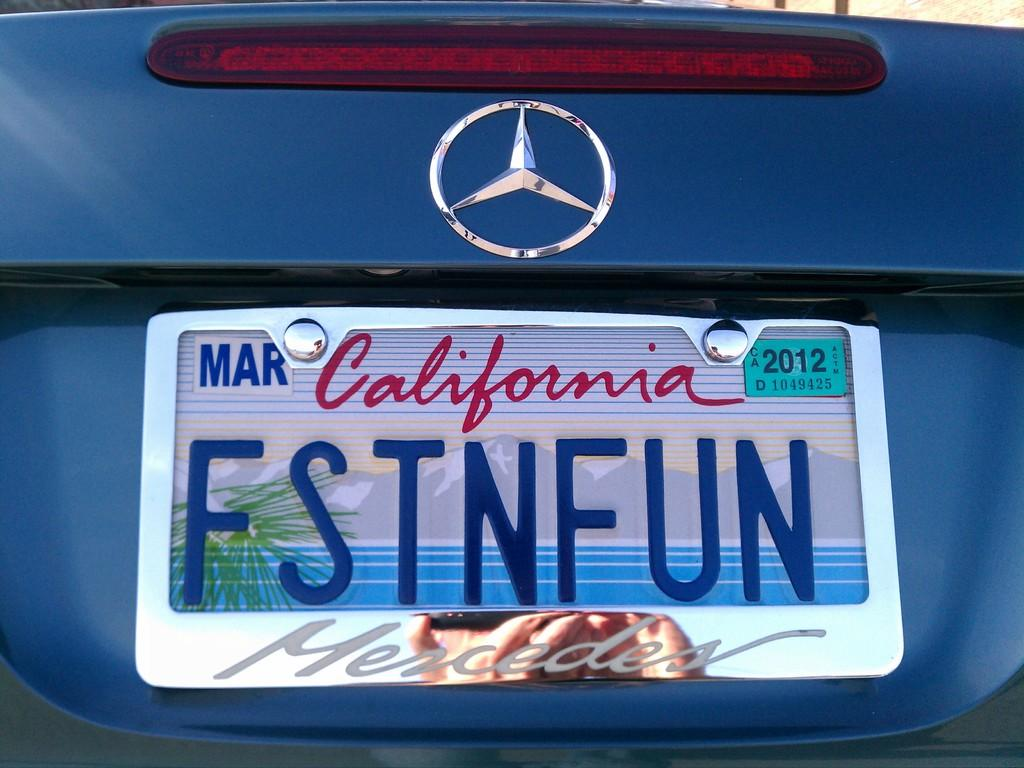<image>
Share a concise interpretation of the image provided. A personalized California liscense plate on a Mercedes 